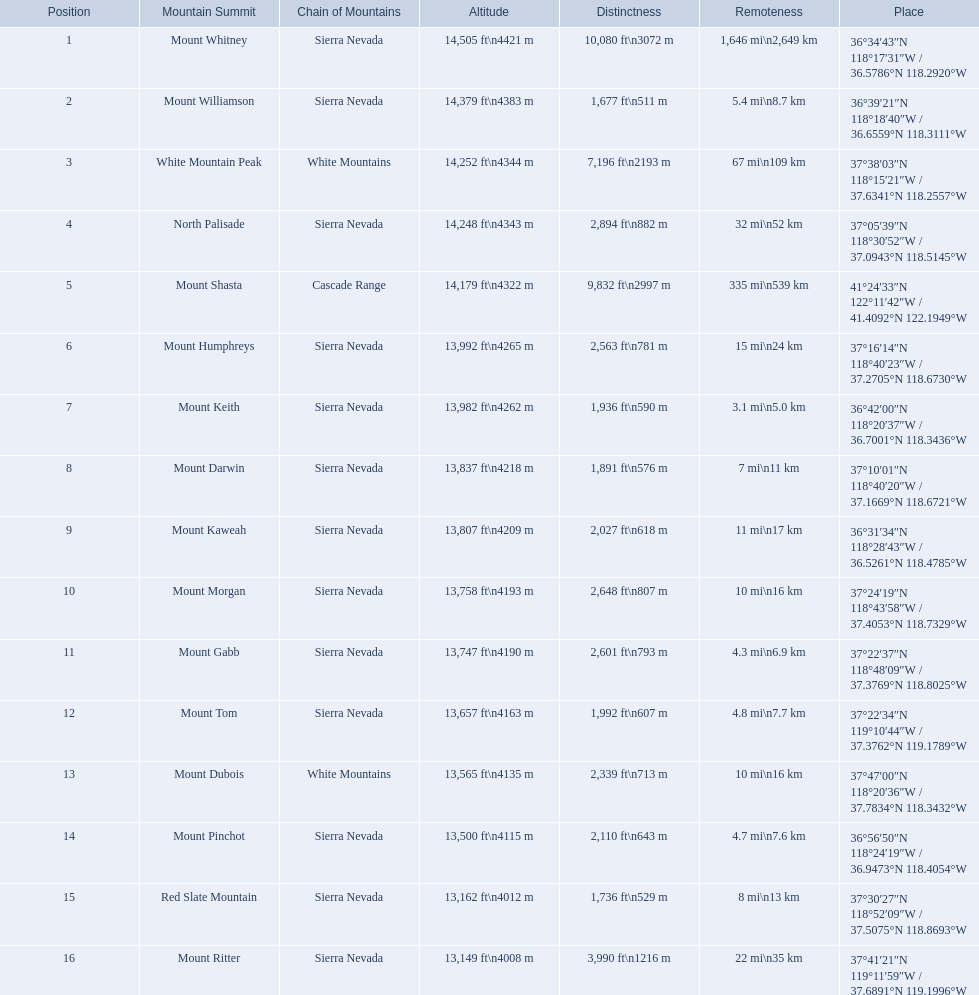Which mountain peak is in the white mountains range? White Mountain Peak. Which mountain is in the sierra nevada range? Mount Whitney. Which mountain is the only one in the cascade range? Mount Shasta. 